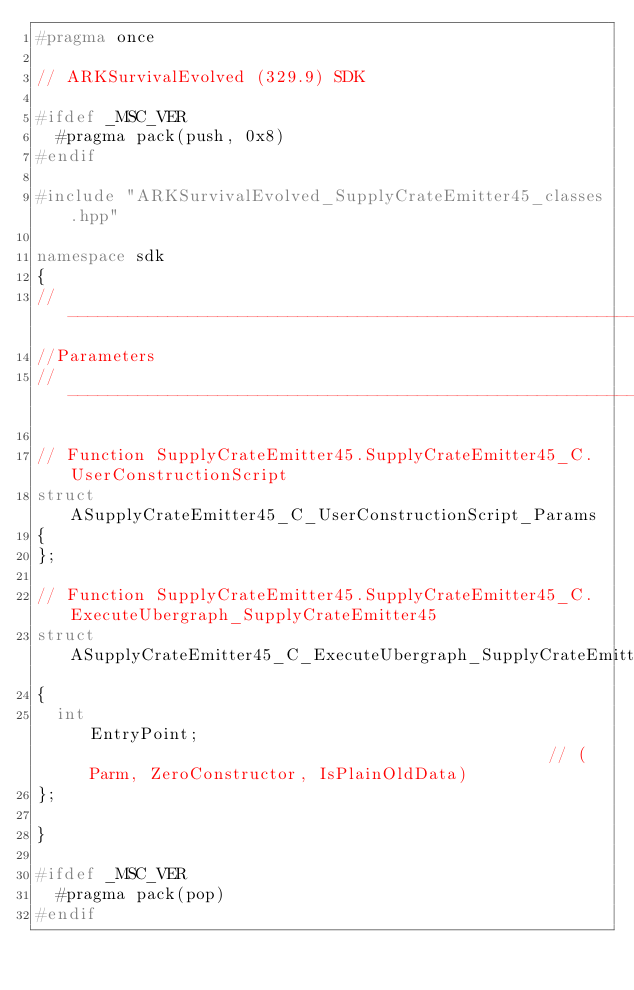Convert code to text. <code><loc_0><loc_0><loc_500><loc_500><_C++_>#pragma once

// ARKSurvivalEvolved (329.9) SDK

#ifdef _MSC_VER
	#pragma pack(push, 0x8)
#endif

#include "ARKSurvivalEvolved_SupplyCrateEmitter45_classes.hpp"

namespace sdk
{
//---------------------------------------------------------------------------
//Parameters
//---------------------------------------------------------------------------

// Function SupplyCrateEmitter45.SupplyCrateEmitter45_C.UserConstructionScript
struct ASupplyCrateEmitter45_C_UserConstructionScript_Params
{
};

// Function SupplyCrateEmitter45.SupplyCrateEmitter45_C.ExecuteUbergraph_SupplyCrateEmitter45
struct ASupplyCrateEmitter45_C_ExecuteUbergraph_SupplyCrateEmitter45_Params
{
	int                                                EntryPoint;                                               // (Parm, ZeroConstructor, IsPlainOldData)
};

}

#ifdef _MSC_VER
	#pragma pack(pop)
#endif
</code> 